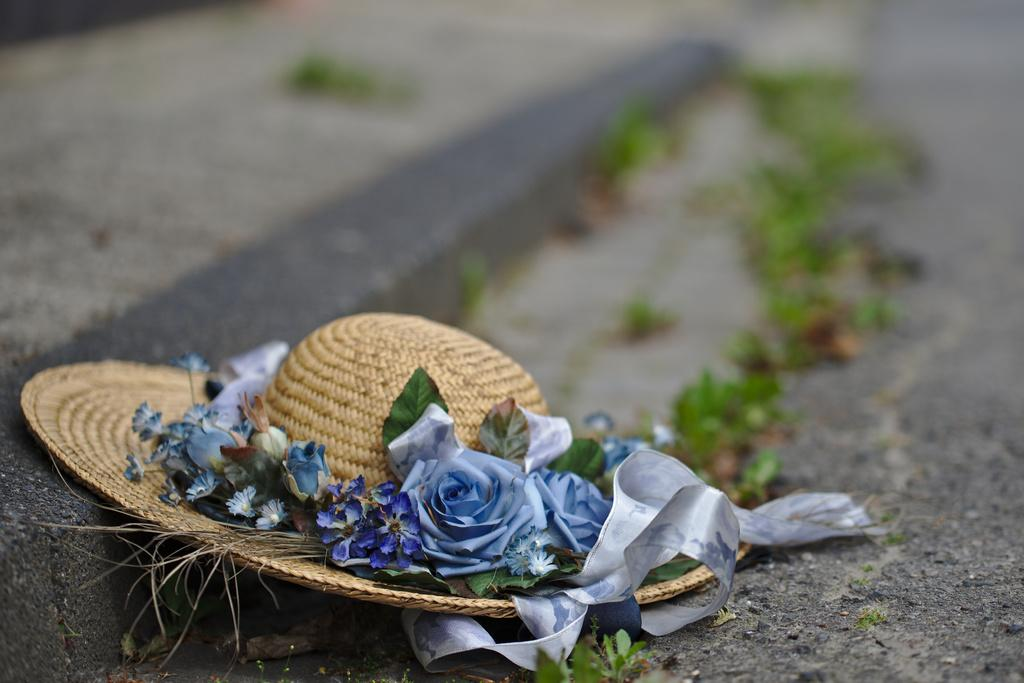What is on the ground in the image? There is a hat on the ground in the image. What can be seen in the background of the image? There are leaves visible in the background of the image. What type of transport can be seen in the image? There is no transport visible in the image; it only features a hat on the ground and leaves in the background. Is there a crook present in the image? There is no crook present in the image. 